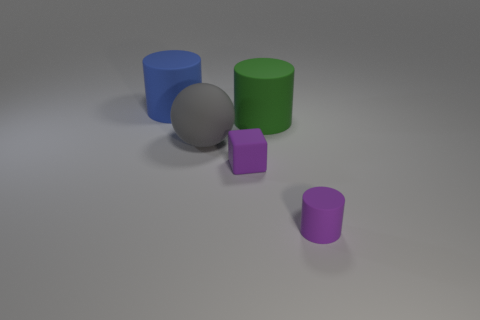Does the small cube have the same material as the gray ball?
Your response must be concise. Yes. There is a cylinder that is the same color as the tiny matte block; what is its size?
Your answer should be very brief. Small. Are there any large matte things of the same color as the matte sphere?
Keep it short and to the point. No. What is the size of the ball that is the same material as the purple block?
Ensure brevity in your answer.  Large. There is a purple rubber thing that is in front of the purple rubber object that is left of the large rubber cylinder that is right of the big blue object; what shape is it?
Provide a succinct answer. Cylinder. There is a purple object that is the same shape as the green thing; what is its size?
Offer a terse response. Small. There is a object that is both on the right side of the matte block and in front of the big gray ball; what is its size?
Keep it short and to the point. Small. What shape is the object that is the same color as the small cylinder?
Make the answer very short. Cube. What color is the large sphere?
Your answer should be compact. Gray. What size is the rubber cylinder in front of the big sphere?
Keep it short and to the point. Small. 